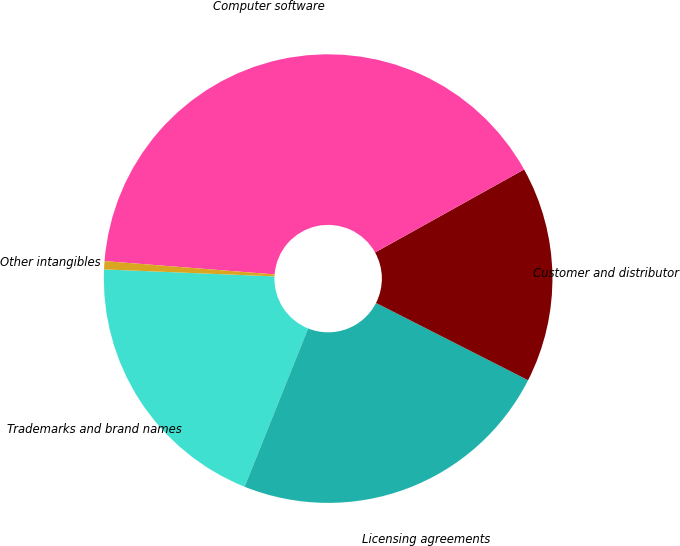Convert chart. <chart><loc_0><loc_0><loc_500><loc_500><pie_chart><fcel>Trademarks and brand names<fcel>Licensing agreements<fcel>Customer and distributor<fcel>Computer software<fcel>Other intangibles<nl><fcel>19.58%<fcel>23.59%<fcel>15.57%<fcel>40.67%<fcel>0.59%<nl></chart> 